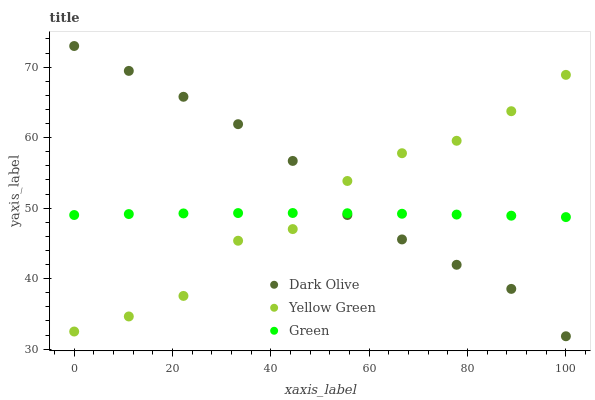Does Green have the minimum area under the curve?
Answer yes or no. Yes. Does Dark Olive have the maximum area under the curve?
Answer yes or no. Yes. Does Yellow Green have the minimum area under the curve?
Answer yes or no. No. Does Yellow Green have the maximum area under the curve?
Answer yes or no. No. Is Green the smoothest?
Answer yes or no. Yes. Is Yellow Green the roughest?
Answer yes or no. Yes. Is Yellow Green the smoothest?
Answer yes or no. No. Is Green the roughest?
Answer yes or no. No. Does Dark Olive have the lowest value?
Answer yes or no. Yes. Does Yellow Green have the lowest value?
Answer yes or no. No. Does Dark Olive have the highest value?
Answer yes or no. Yes. Does Yellow Green have the highest value?
Answer yes or no. No. Does Green intersect Dark Olive?
Answer yes or no. Yes. Is Green less than Dark Olive?
Answer yes or no. No. Is Green greater than Dark Olive?
Answer yes or no. No. 